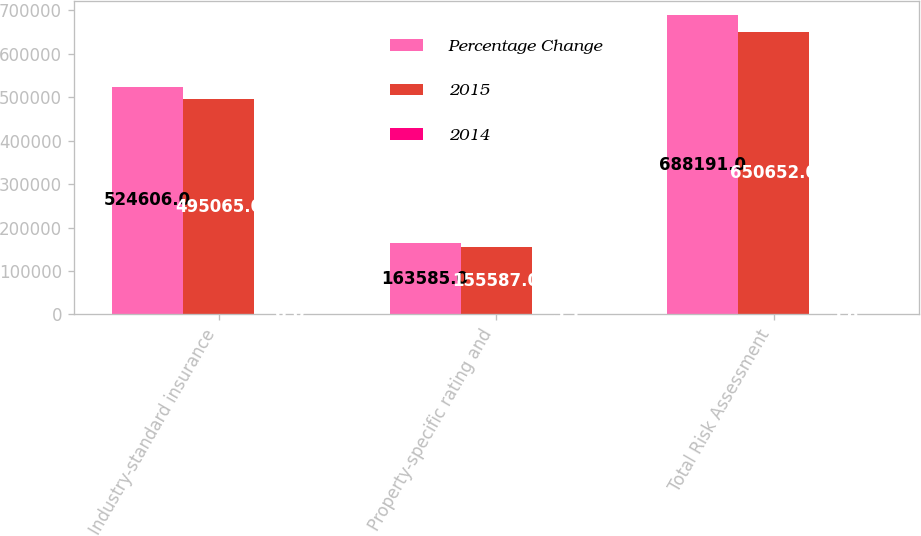Convert chart to OTSL. <chart><loc_0><loc_0><loc_500><loc_500><stacked_bar_chart><ecel><fcel>Industry-standard insurance<fcel>Property-specific rating and<fcel>Total Risk Assessment<nl><fcel>Percentage Change<fcel>524606<fcel>163585<fcel>688191<nl><fcel>2015<fcel>495065<fcel>155587<fcel>650652<nl><fcel>2014<fcel>6<fcel>5.1<fcel>5.8<nl></chart> 